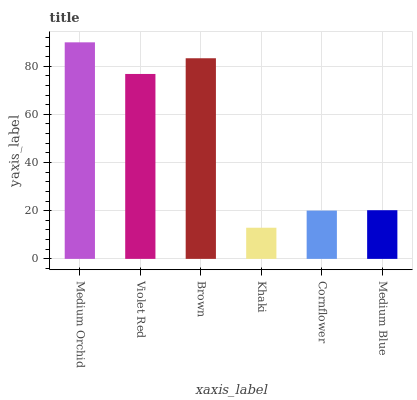Is Khaki the minimum?
Answer yes or no. Yes. Is Medium Orchid the maximum?
Answer yes or no. Yes. Is Violet Red the minimum?
Answer yes or no. No. Is Violet Red the maximum?
Answer yes or no. No. Is Medium Orchid greater than Violet Red?
Answer yes or no. Yes. Is Violet Red less than Medium Orchid?
Answer yes or no. Yes. Is Violet Red greater than Medium Orchid?
Answer yes or no. No. Is Medium Orchid less than Violet Red?
Answer yes or no. No. Is Violet Red the high median?
Answer yes or no. Yes. Is Medium Blue the low median?
Answer yes or no. Yes. Is Medium Orchid the high median?
Answer yes or no. No. Is Brown the low median?
Answer yes or no. No. 